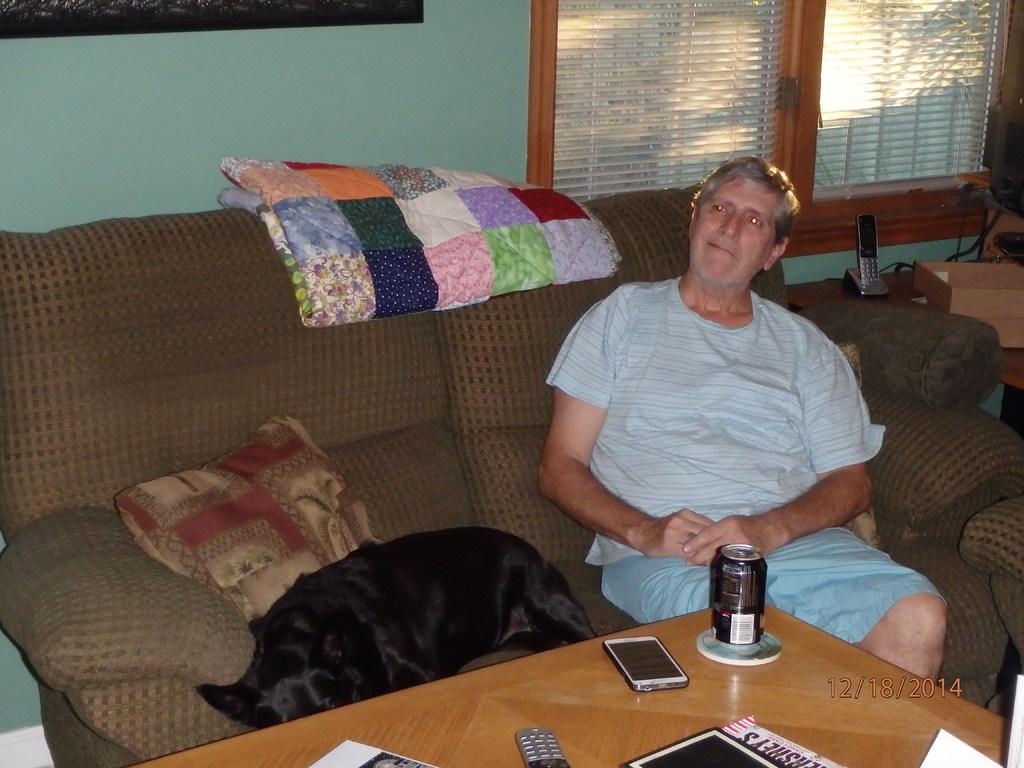How would you summarize this image in a sentence or two? In this picture we can see couch. On the couch we can see person,bed sheet,pillow,dog. There is a table. On the table We can see in,mobile,phone,paper. On the background we can see wall. window. This is mobile. This is table. 